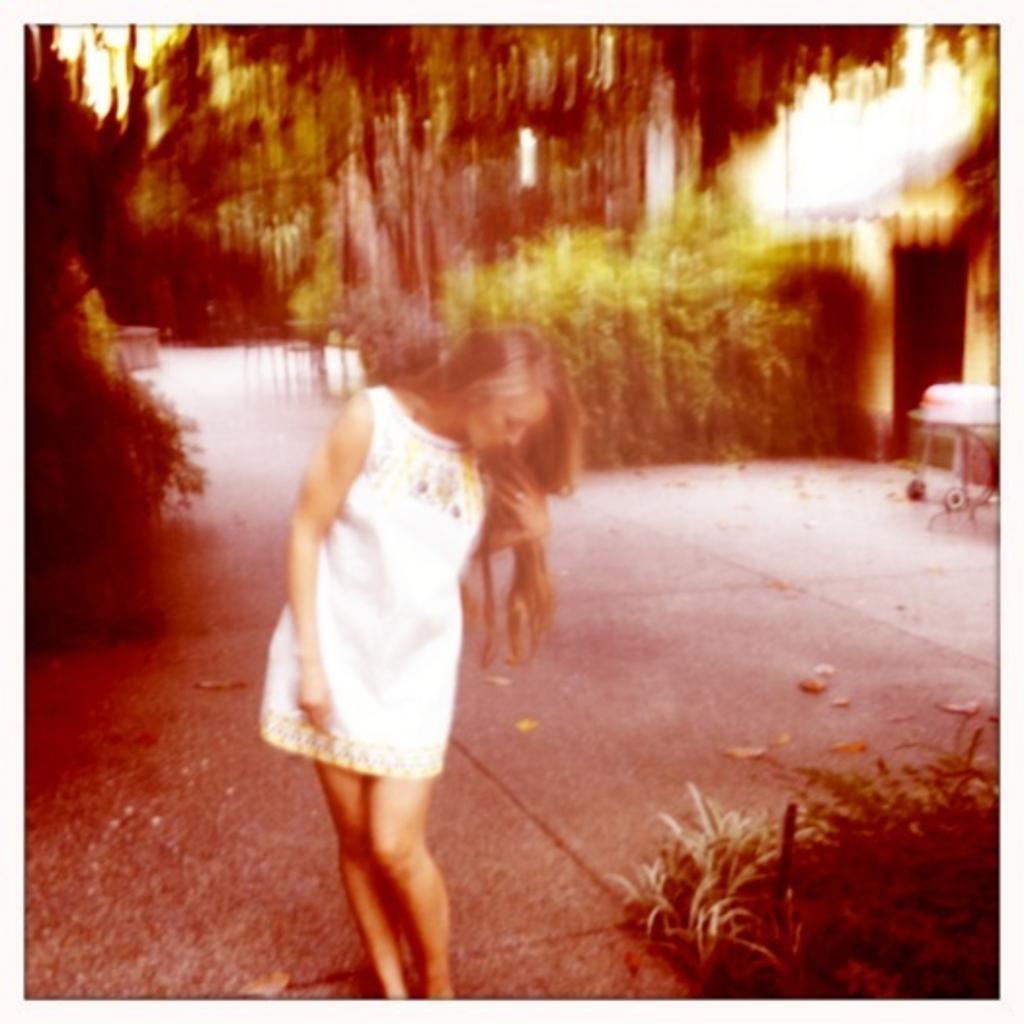Please provide a concise description of this image. This image is slightly blurred, where we can see a woman wearing white color dress is standing on the road. Here we can see the grass, some objects and the trees in the background. 